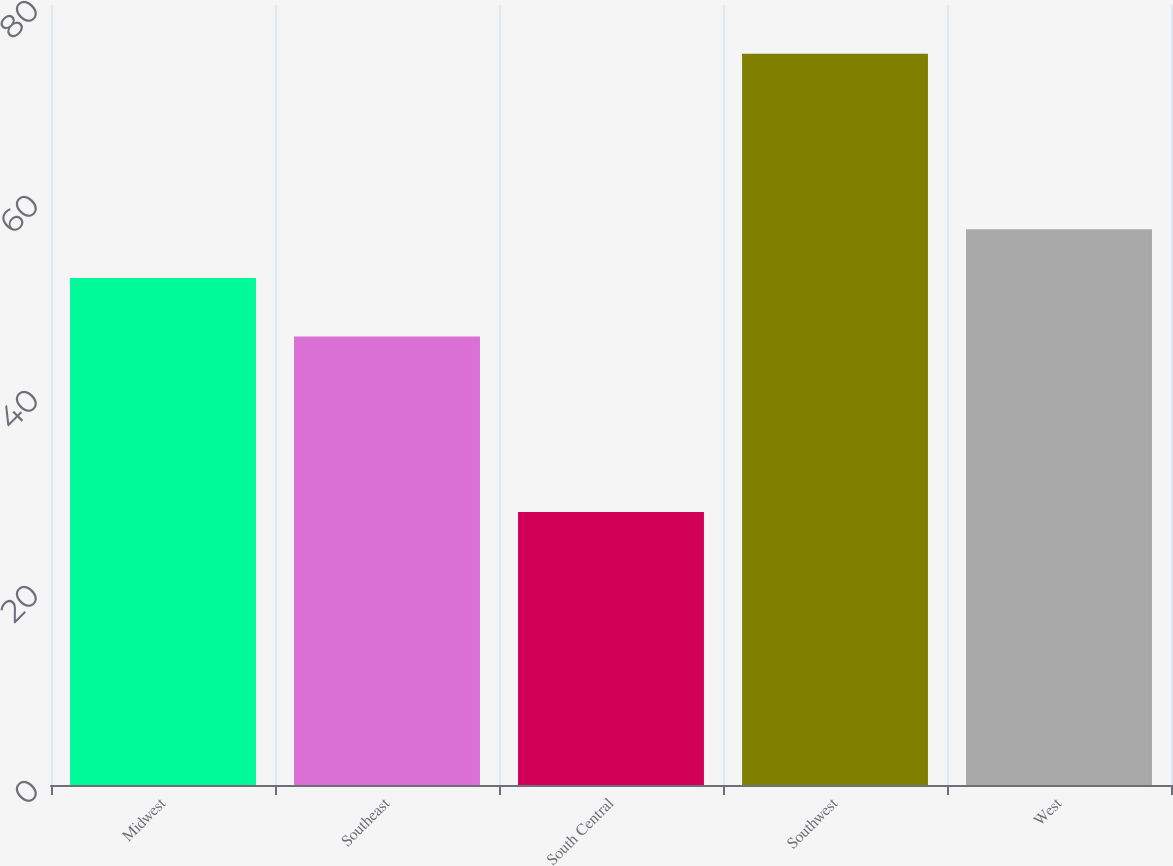Convert chart to OTSL. <chart><loc_0><loc_0><loc_500><loc_500><bar_chart><fcel>Midwest<fcel>Southeast<fcel>South Central<fcel>Southwest<fcel>West<nl><fcel>52<fcel>46<fcel>28<fcel>75<fcel>57<nl></chart> 